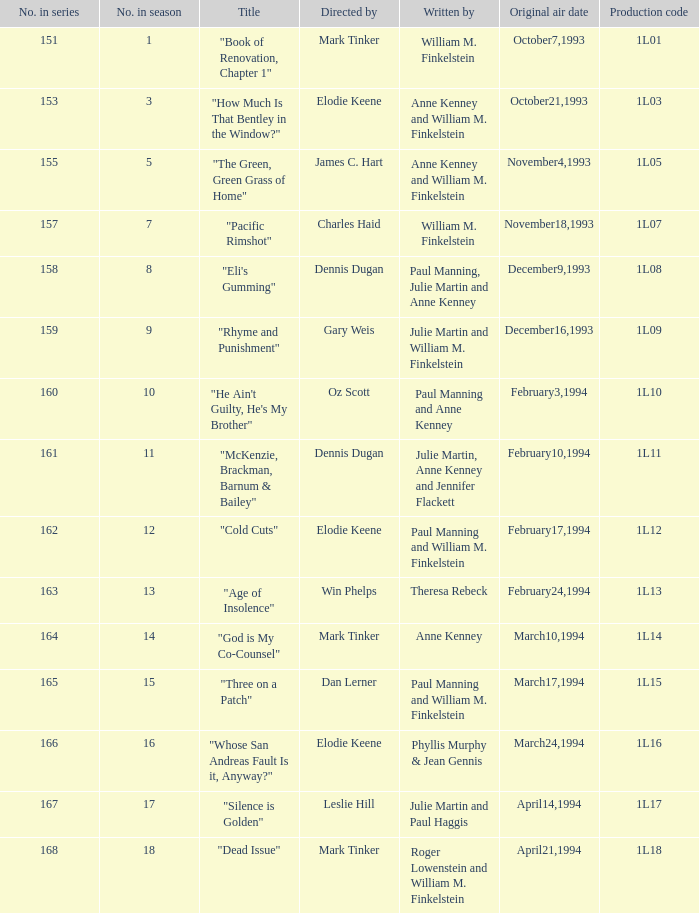I'm looking to parse the entire table for insights. Could you assist me with that? {'header': ['No. in series', 'No. in season', 'Title', 'Directed by', 'Written by', 'Original air date', 'Production code'], 'rows': [['151', '1', '"Book of Renovation, Chapter 1"', 'Mark Tinker', 'William M. Finkelstein', 'October7,1993', '1L01'], ['153', '3', '"How Much Is That Bentley in the Window?"', 'Elodie Keene', 'Anne Kenney and William M. Finkelstein', 'October21,1993', '1L03'], ['155', '5', '"The Green, Green Grass of Home"', 'James C. Hart', 'Anne Kenney and William M. Finkelstein', 'November4,1993', '1L05'], ['157', '7', '"Pacific Rimshot"', 'Charles Haid', 'William M. Finkelstein', 'November18,1993', '1L07'], ['158', '8', '"Eli\'s Gumming"', 'Dennis Dugan', 'Paul Manning, Julie Martin and Anne Kenney', 'December9,1993', '1L08'], ['159', '9', '"Rhyme and Punishment"', 'Gary Weis', 'Julie Martin and William M. Finkelstein', 'December16,1993', '1L09'], ['160', '10', '"He Ain\'t Guilty, He\'s My Brother"', 'Oz Scott', 'Paul Manning and Anne Kenney', 'February3,1994', '1L10'], ['161', '11', '"McKenzie, Brackman, Barnum & Bailey"', 'Dennis Dugan', 'Julie Martin, Anne Kenney and Jennifer Flackett', 'February10,1994', '1L11'], ['162', '12', '"Cold Cuts"', 'Elodie Keene', 'Paul Manning and William M. Finkelstein', 'February17,1994', '1L12'], ['163', '13', '"Age of Insolence"', 'Win Phelps', 'Theresa Rebeck', 'February24,1994', '1L13'], ['164', '14', '"God is My Co-Counsel"', 'Mark Tinker', 'Anne Kenney', 'March10,1994', '1L14'], ['165', '15', '"Three on a Patch"', 'Dan Lerner', 'Paul Manning and William M. Finkelstein', 'March17,1994', '1L15'], ['166', '16', '"Whose San Andreas Fault Is it, Anyway?"', 'Elodie Keene', 'Phyllis Murphy & Jean Gennis', 'March24,1994', '1L16'], ['167', '17', '"Silence is Golden"', 'Leslie Hill', 'Julie Martin and Paul Haggis', 'April14,1994', '1L17'], ['168', '18', '"Dead Issue"', 'Mark Tinker', 'Roger Lowenstein and William M. Finkelstein', 'April21,1994', '1L18']]} Name who directed the production code 1l10 Oz Scott. 